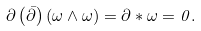<formula> <loc_0><loc_0><loc_500><loc_500>\partial \left ( \bar { \partial } \right ) \left ( \omega \wedge \omega \right ) = \partial \ast \omega = 0 .</formula> 